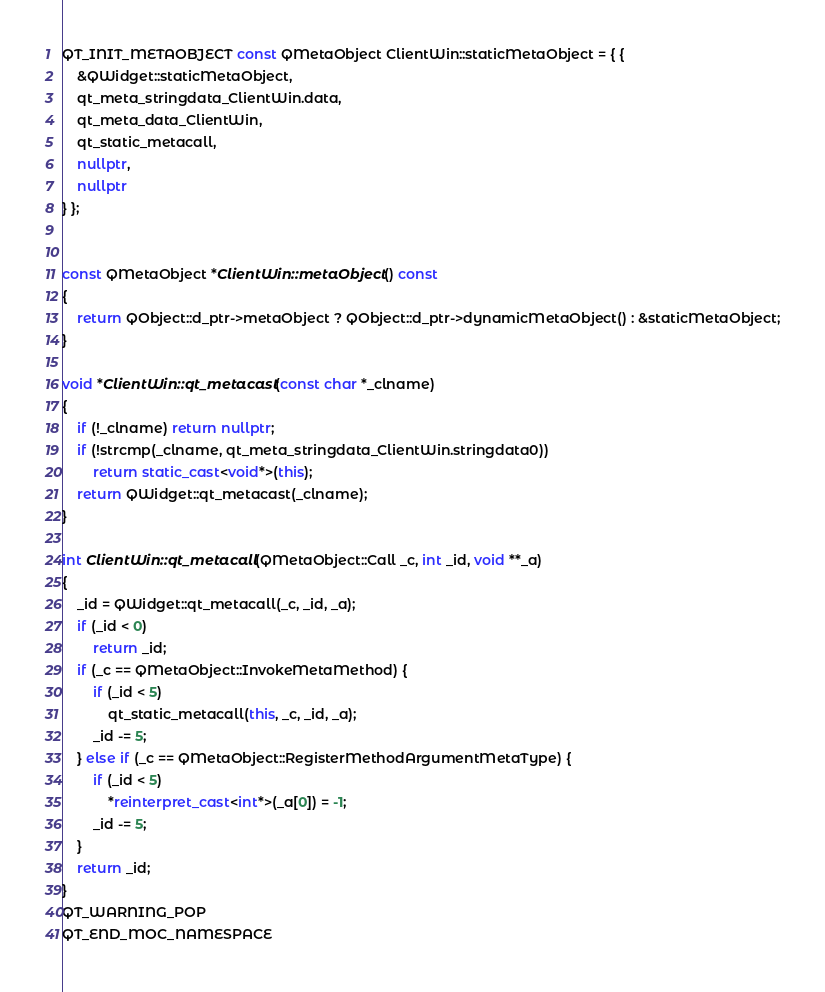Convert code to text. <code><loc_0><loc_0><loc_500><loc_500><_C++_>
QT_INIT_METAOBJECT const QMetaObject ClientWin::staticMetaObject = { {
    &QWidget::staticMetaObject,
    qt_meta_stringdata_ClientWin.data,
    qt_meta_data_ClientWin,
    qt_static_metacall,
    nullptr,
    nullptr
} };


const QMetaObject *ClientWin::metaObject() const
{
    return QObject::d_ptr->metaObject ? QObject::d_ptr->dynamicMetaObject() : &staticMetaObject;
}

void *ClientWin::qt_metacast(const char *_clname)
{
    if (!_clname) return nullptr;
    if (!strcmp(_clname, qt_meta_stringdata_ClientWin.stringdata0))
        return static_cast<void*>(this);
    return QWidget::qt_metacast(_clname);
}

int ClientWin::qt_metacall(QMetaObject::Call _c, int _id, void **_a)
{
    _id = QWidget::qt_metacall(_c, _id, _a);
    if (_id < 0)
        return _id;
    if (_c == QMetaObject::InvokeMetaMethod) {
        if (_id < 5)
            qt_static_metacall(this, _c, _id, _a);
        _id -= 5;
    } else if (_c == QMetaObject::RegisterMethodArgumentMetaType) {
        if (_id < 5)
            *reinterpret_cast<int*>(_a[0]) = -1;
        _id -= 5;
    }
    return _id;
}
QT_WARNING_POP
QT_END_MOC_NAMESPACE
</code> 